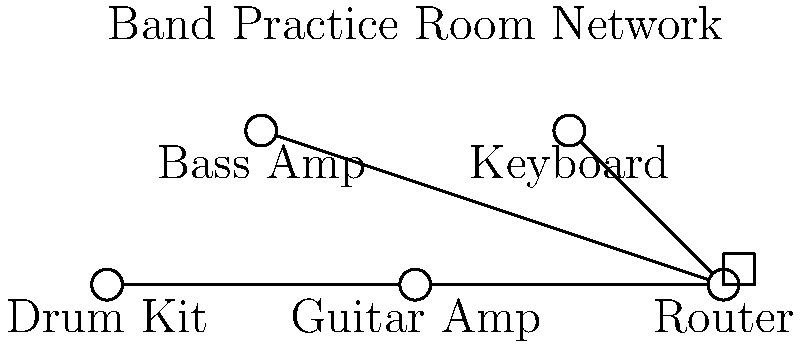In the network diagram for a band practice room, what type of network topology is being used to connect the musical instruments and amplifiers to the central router? To determine the network topology used in this band practice room, let's analyze the diagram step-by-step:

1. Observe the connections: Each device (Drum Kit, Bass Amp, Guitar Amp, and Keyboard) is directly connected to the central Router.

2. Notice the central point: The Router acts as a central hub to which all other devices are connected.

3. Identify the pattern: There are no connections between the devices themselves; all connections go through the Router.

4. Recall network topologies: This pattern matches the characteristics of a star topology.

5. Define star topology: In a star topology, all devices are connected to a central node (in this case, the Router) through point-to-point links.

6. Advantages for a band room:
   - Easy to add or remove devices without disrupting the network
   - If one connection fails, other devices are not affected
   - Centralized management through the router

7. Relevance to the band room: This topology allows each instrument or amp to have a dedicated connection to the network, which could be useful for digital audio routing or remote control of equipment.

Based on these observations and analysis, the network topology used in this band practice room is a star topology.
Answer: Star topology 